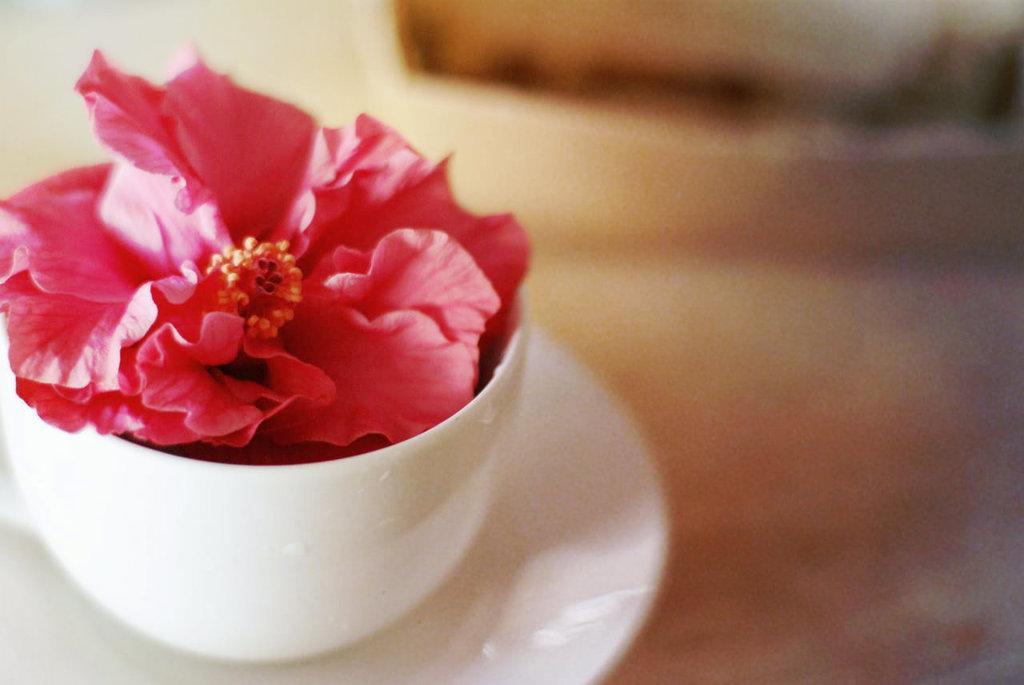Can you describe this image briefly? In this image I can see the flower in the cup. I can see the cup is on the saucer. I can see the blurred background. 